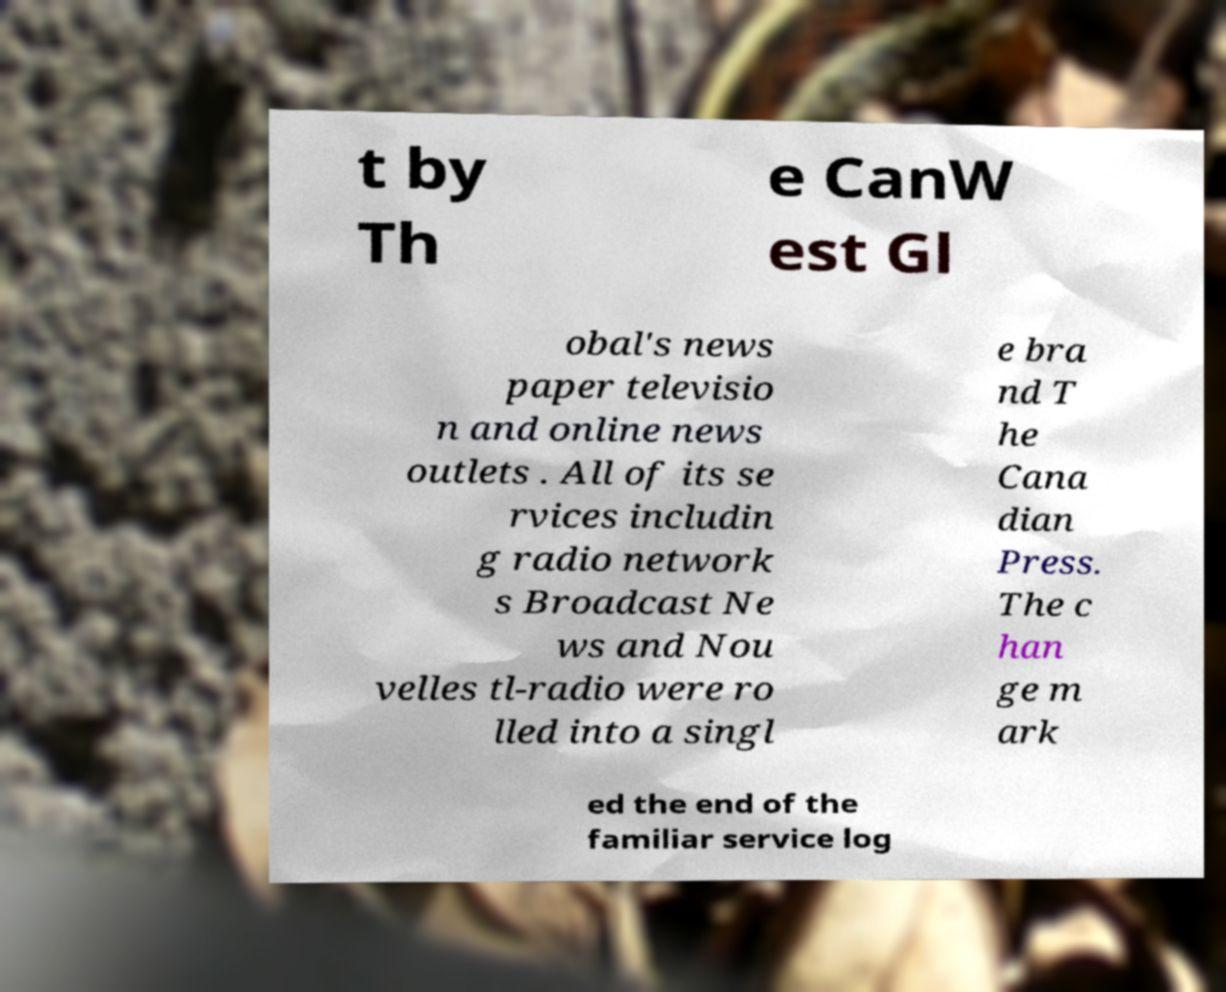Can you read and provide the text displayed in the image?This photo seems to have some interesting text. Can you extract and type it out for me? t by Th e CanW est Gl obal's news paper televisio n and online news outlets . All of its se rvices includin g radio network s Broadcast Ne ws and Nou velles tl-radio were ro lled into a singl e bra nd T he Cana dian Press. The c han ge m ark ed the end of the familiar service log 